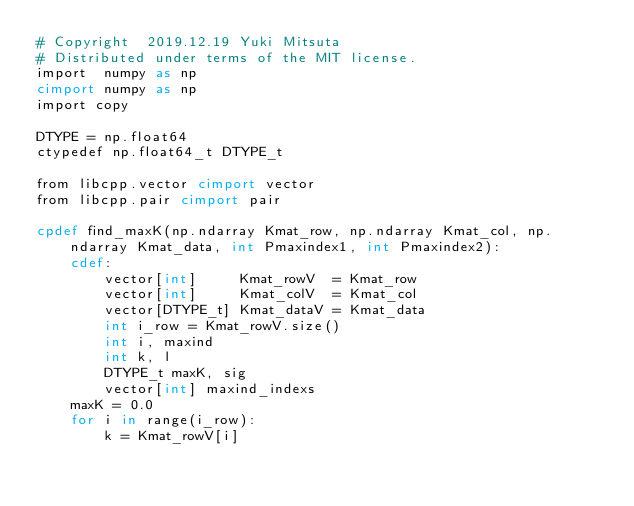<code> <loc_0><loc_0><loc_500><loc_500><_Cython_># Copyright  2019.12.19 Yuki Mitsuta
# Distributed under terms of the MIT license.
import  numpy as np
cimport numpy as np
import copy

DTYPE = np.float64
ctypedef np.float64_t DTYPE_t

from libcpp.vector cimport vector
from libcpp.pair cimport pair

cpdef find_maxK(np.ndarray Kmat_row, np.ndarray Kmat_col, np.ndarray Kmat_data, int Pmaxindex1, int Pmaxindex2):
    cdef:
        vector[int]     Kmat_rowV  = Kmat_row
        vector[int]     Kmat_colV  = Kmat_col
        vector[DTYPE_t] Kmat_dataV = Kmat_data
        int i_row = Kmat_rowV.size()
        int i, maxind
        int k, l
        DTYPE_t maxK, sig
        vector[int] maxind_indexs
    maxK = 0.0
    for i in range(i_row):
        k = Kmat_rowV[i]</code> 